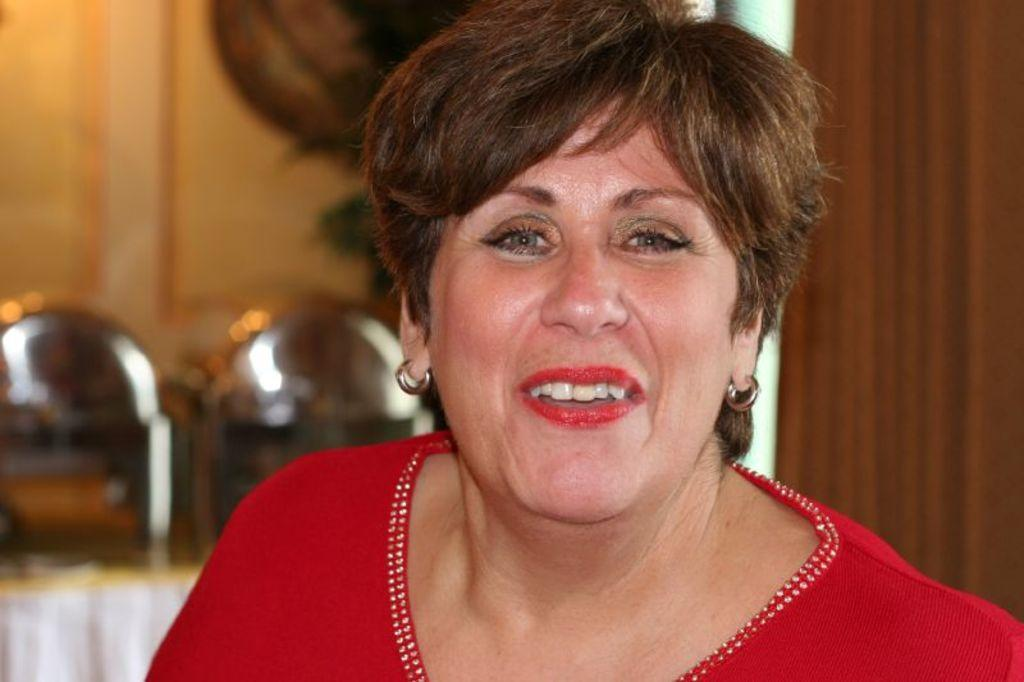Who is the main subject in the image? There is a woman in the image. What is the woman wearing? The woman is wearing a red dress and red lipstick. What can be seen in the background of the image? There is a brown colored surface and blurry objects in the background of the image. What type of insect can be seen crawling on the woman's dress in the image? There is no insect present on the woman's dress in the image. What property does the woman own in the image? The image does not provide information about the woman owning any property. 